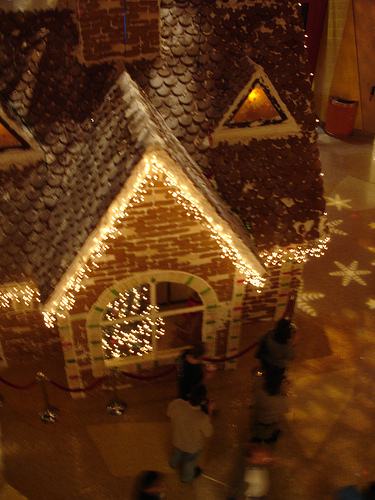<image>
Is the lights on the floor? No. The lights is not positioned on the floor. They may be near each other, but the lights is not supported by or resting on top of the floor. 